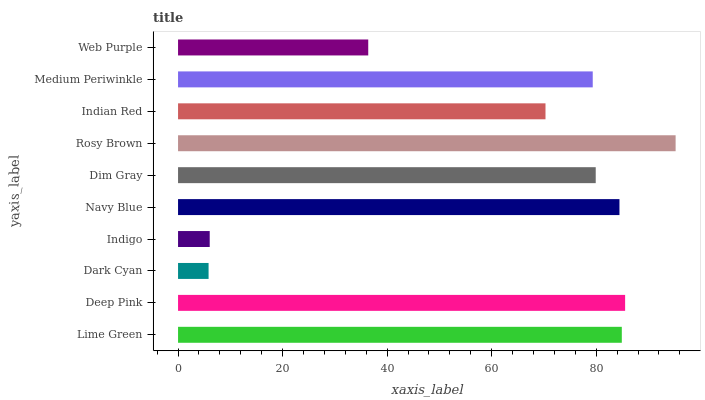Is Dark Cyan the minimum?
Answer yes or no. Yes. Is Rosy Brown the maximum?
Answer yes or no. Yes. Is Deep Pink the minimum?
Answer yes or no. No. Is Deep Pink the maximum?
Answer yes or no. No. Is Deep Pink greater than Lime Green?
Answer yes or no. Yes. Is Lime Green less than Deep Pink?
Answer yes or no. Yes. Is Lime Green greater than Deep Pink?
Answer yes or no. No. Is Deep Pink less than Lime Green?
Answer yes or no. No. Is Dim Gray the high median?
Answer yes or no. Yes. Is Medium Periwinkle the low median?
Answer yes or no. Yes. Is Indian Red the high median?
Answer yes or no. No. Is Dim Gray the low median?
Answer yes or no. No. 